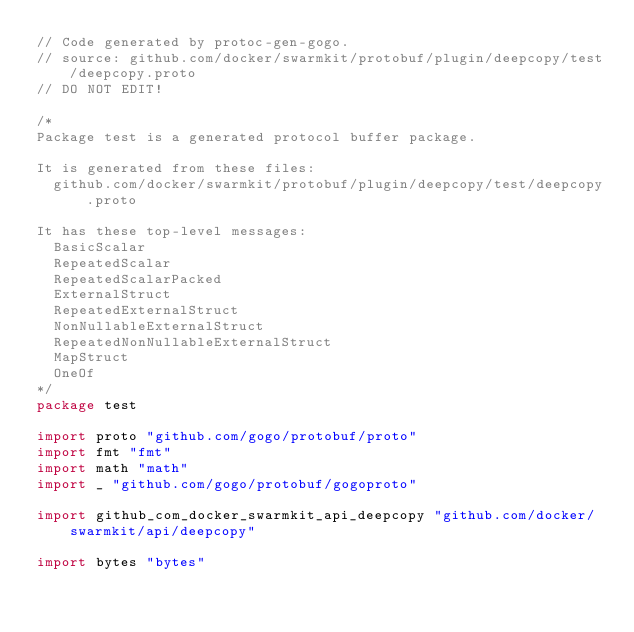<code> <loc_0><loc_0><loc_500><loc_500><_Go_>// Code generated by protoc-gen-gogo.
// source: github.com/docker/swarmkit/protobuf/plugin/deepcopy/test/deepcopy.proto
// DO NOT EDIT!

/*
Package test is a generated protocol buffer package.

It is generated from these files:
	github.com/docker/swarmkit/protobuf/plugin/deepcopy/test/deepcopy.proto

It has these top-level messages:
	BasicScalar
	RepeatedScalar
	RepeatedScalarPacked
	ExternalStruct
	RepeatedExternalStruct
	NonNullableExternalStruct
	RepeatedNonNullableExternalStruct
	MapStruct
	OneOf
*/
package test

import proto "github.com/gogo/protobuf/proto"
import fmt "fmt"
import math "math"
import _ "github.com/gogo/protobuf/gogoproto"

import github_com_docker_swarmkit_api_deepcopy "github.com/docker/swarmkit/api/deepcopy"

import bytes "bytes"
</code> 